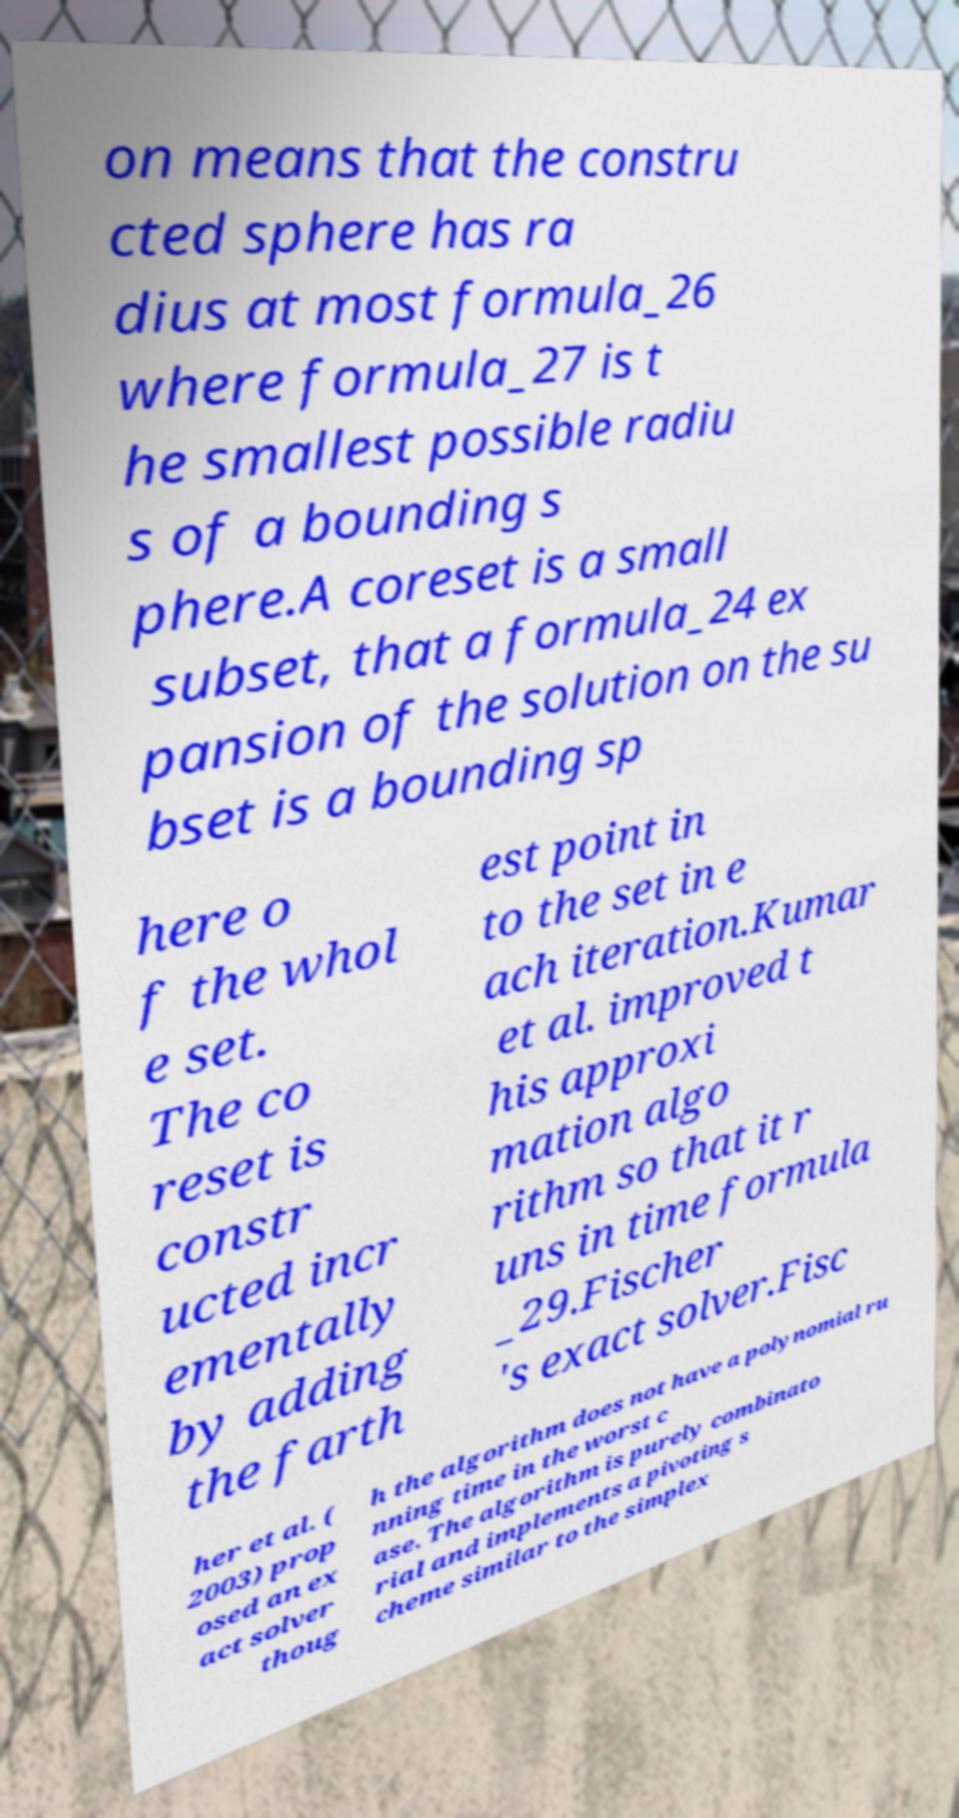Please identify and transcribe the text found in this image. on means that the constru cted sphere has ra dius at most formula_26 where formula_27 is t he smallest possible radiu s of a bounding s phere.A coreset is a small subset, that a formula_24 ex pansion of the solution on the su bset is a bounding sp here o f the whol e set. The co reset is constr ucted incr ementally by adding the farth est point in to the set in e ach iteration.Kumar et al. improved t his approxi mation algo rithm so that it r uns in time formula _29.Fischer 's exact solver.Fisc her et al. ( 2003) prop osed an ex act solver thoug h the algorithm does not have a polynomial ru nning time in the worst c ase. The algorithm is purely combinato rial and implements a pivoting s cheme similar to the simplex 